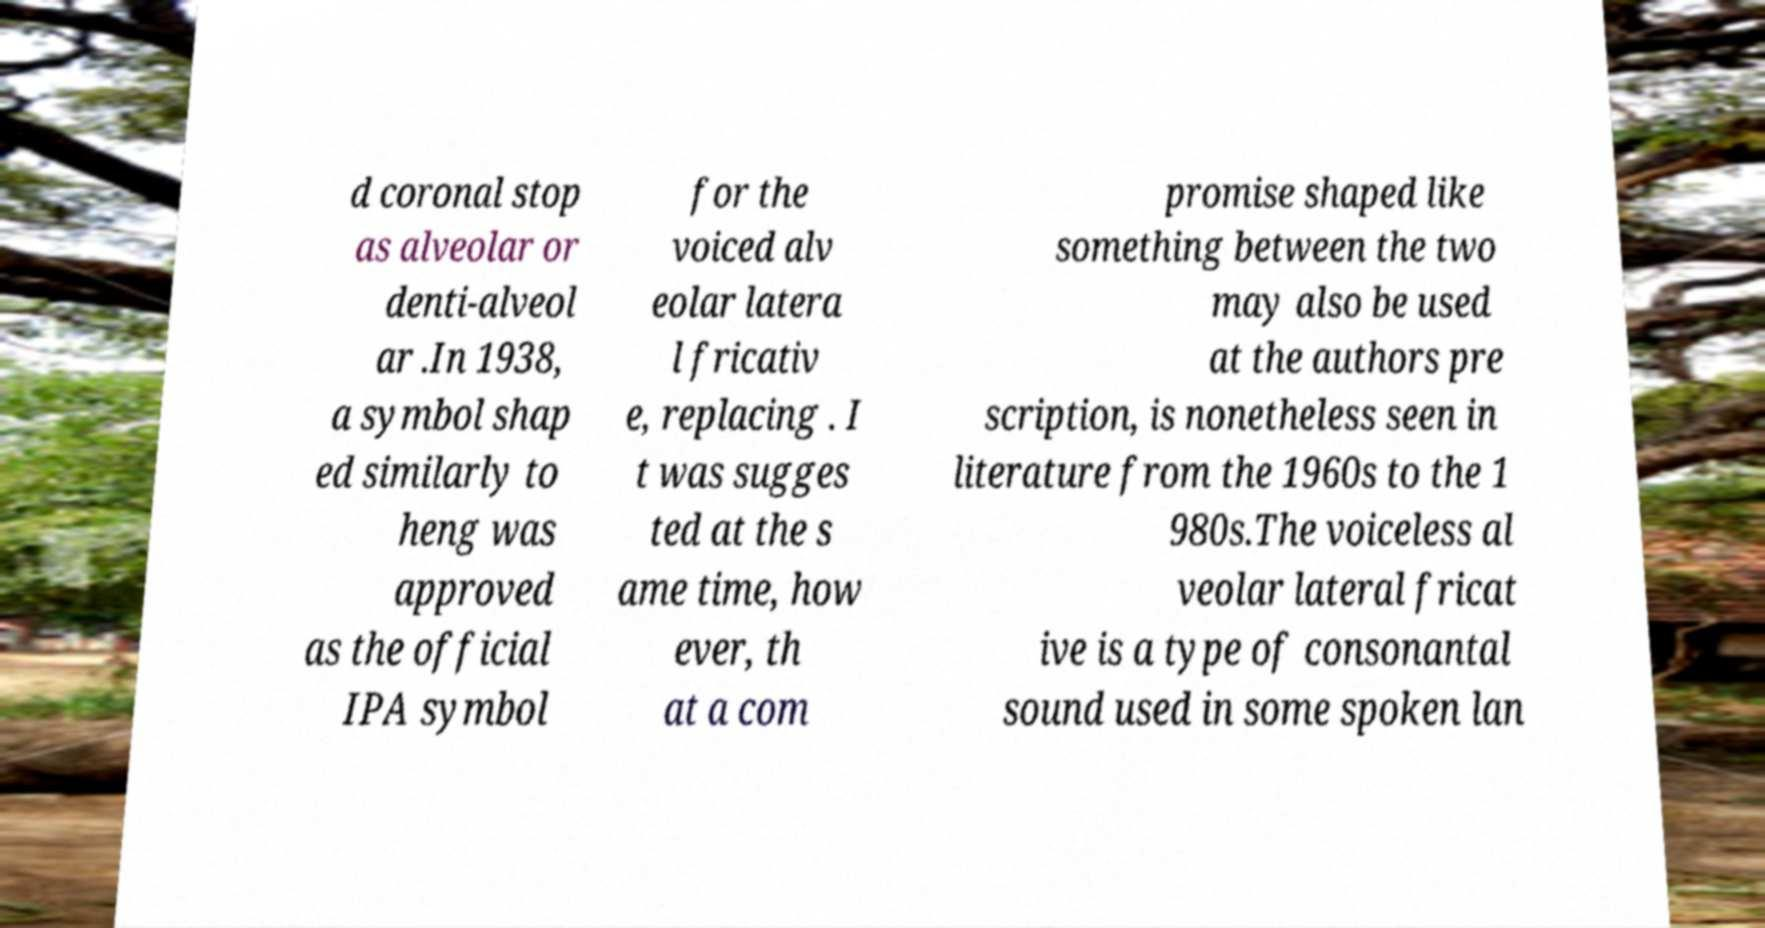For documentation purposes, I need the text within this image transcribed. Could you provide that? d coronal stop as alveolar or denti-alveol ar .In 1938, a symbol shap ed similarly to heng was approved as the official IPA symbol for the voiced alv eolar latera l fricativ e, replacing . I t was sugges ted at the s ame time, how ever, th at a com promise shaped like something between the two may also be used at the authors pre scription, is nonetheless seen in literature from the 1960s to the 1 980s.The voiceless al veolar lateral fricat ive is a type of consonantal sound used in some spoken lan 